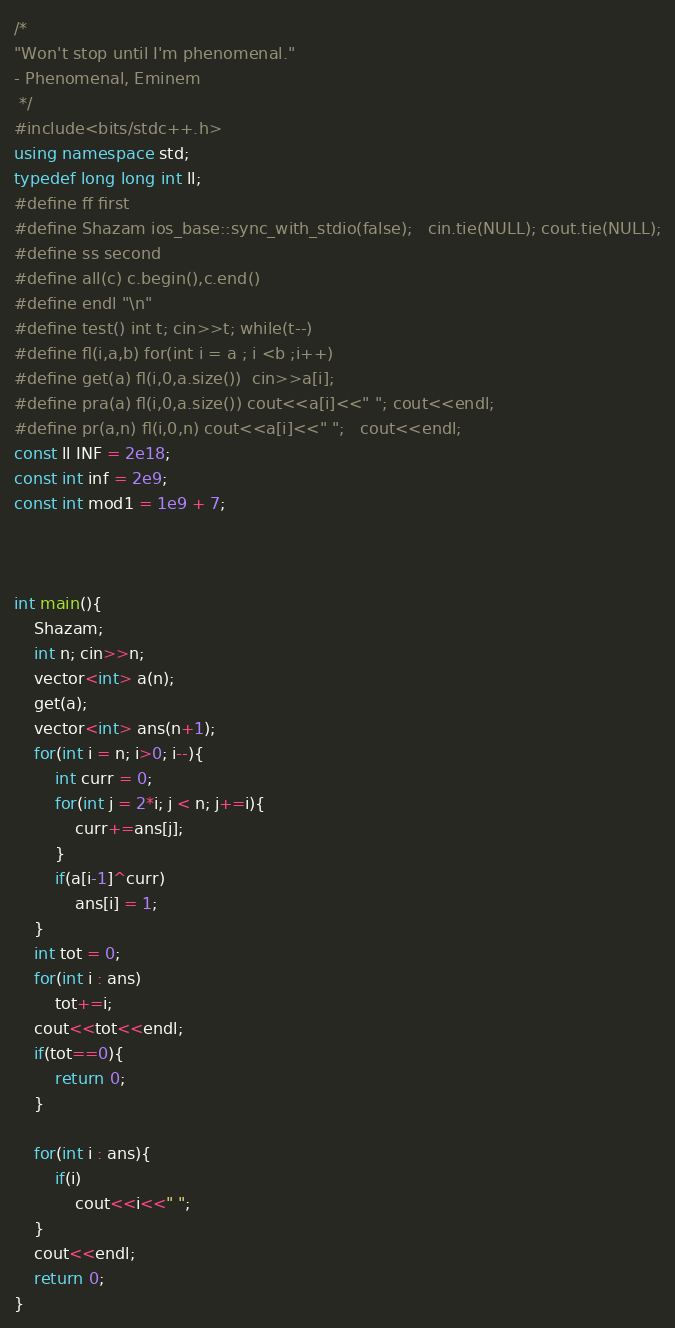Convert code to text. <code><loc_0><loc_0><loc_500><loc_500><_C++_>/*
"Won't stop until I'm phenomenal."
- Phenomenal, Eminem
 */
#include<bits/stdc++.h>
using namespace std;
typedef long long int ll;
#define ff first
#define Shazam ios_base::sync_with_stdio(false);   cin.tie(NULL); cout.tie(NULL);
#define ss second
#define all(c) c.begin(),c.end()
#define endl "\n"
#define test() int t; cin>>t; while(t--)
#define fl(i,a,b) for(int i = a ; i <b ;i++)
#define get(a) fl(i,0,a.size())  cin>>a[i];
#define pra(a) fl(i,0,a.size()) cout<<a[i]<<" ";	cout<<endl;
#define pr(a,n) fl(i,0,n) cout<<a[i]<<" ";	cout<<endl;
const ll INF = 2e18;
const int inf = 2e9;
const int mod1 = 1e9 + 7;



int main(){
    Shazam;
    int n; cin>>n;
    vector<int> a(n);
    get(a);
    vector<int> ans(n+1);
    for(int i = n; i>0; i--){
        int curr = 0;
        for(int j = 2*i; j < n; j+=i){
            curr+=ans[j];
        }
        if(a[i-1]^curr)
            ans[i] = 1;
    }
    int tot = 0;
    for(int i : ans)
        tot+=i;
    cout<<tot<<endl;
    if(tot==0){ 
        return 0;
    }

    for(int i : ans){
        if(i)
            cout<<i<<" ";
    }
    cout<<endl;
    return 0;
}</code> 